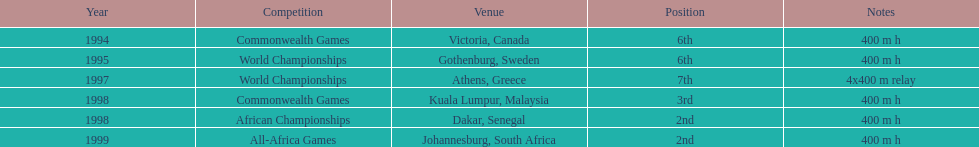What was the venue before dakar, senegal? Kuala Lumpur, Malaysia. 